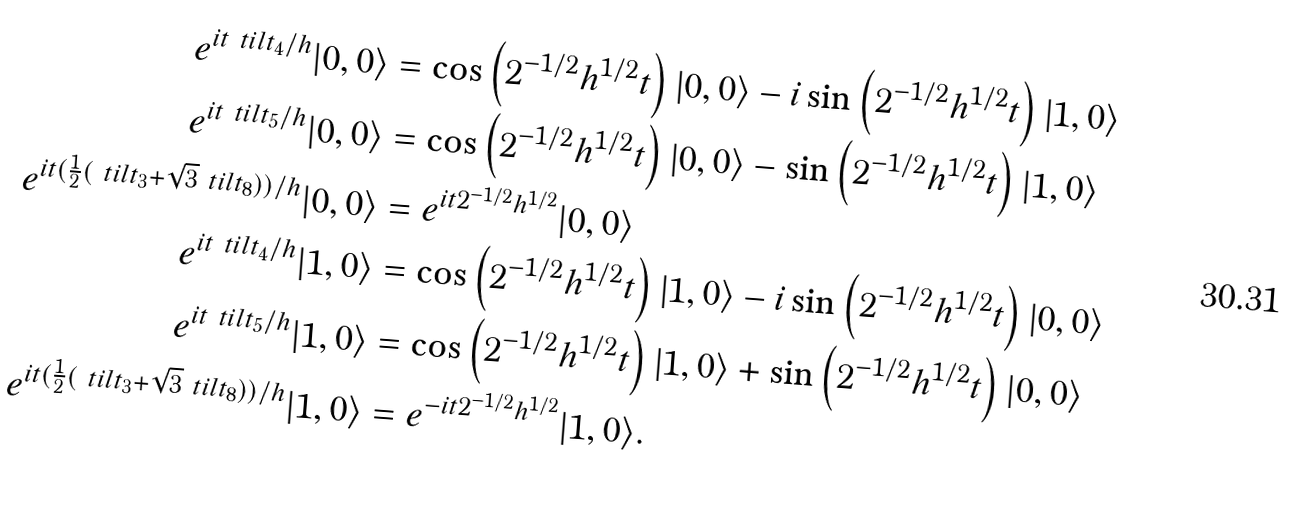<formula> <loc_0><loc_0><loc_500><loc_500>e ^ { i t \ t i l t _ { 4 } / h } | 0 , 0 \rangle & = \cos \left ( 2 ^ { - 1 / 2 } h ^ { 1 / 2 } t \right ) | 0 , 0 \rangle - i \sin \left ( 2 ^ { - 1 / 2 } h ^ { 1 / 2 } t \right ) | 1 , 0 \rangle \\ e ^ { i t \ t i l t _ { 5 } / h } | 0 , 0 \rangle & = \cos \left ( 2 ^ { - 1 / 2 } h ^ { 1 / 2 } t \right ) | 0 , 0 \rangle - \sin \left ( 2 ^ { - 1 / 2 } h ^ { 1 / 2 } t \right ) | 1 , 0 \rangle \\ e ^ { i t ( \frac { 1 } { 2 } ( \ t i l t _ { 3 } + \sqrt { 3 } \ t i l t _ { 8 } ) ) / h } | 0 , 0 \rangle & = e ^ { i t 2 ^ { - 1 / 2 } h ^ { 1 / 2 } } | 0 , 0 \rangle \\ e ^ { i t \ t i l t _ { 4 } / h } | 1 , 0 \rangle & = \cos \left ( 2 ^ { - 1 / 2 } h ^ { 1 / 2 } t \right ) | 1 , 0 \rangle - i \sin \left ( 2 ^ { - 1 / 2 } h ^ { 1 / 2 } t \right ) | 0 , 0 \rangle \\ e ^ { i t \ t i l t _ { 5 } / h } | 1 , 0 \rangle & = \cos \left ( 2 ^ { - 1 / 2 } h ^ { 1 / 2 } t \right ) | 1 , 0 \rangle + \sin \left ( 2 ^ { - 1 / 2 } h ^ { 1 / 2 } t \right ) | 0 , 0 \rangle \\ e ^ { i t ( \frac { 1 } { 2 } ( \ t i l t _ { 3 } + \sqrt { 3 } \ t i l t _ { 8 } ) ) / h } | 1 , 0 \rangle & = e ^ { - i t 2 ^ { - 1 / 2 } h ^ { 1 / 2 } } | 1 , 0 \rangle .</formula> 